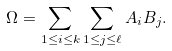Convert formula to latex. <formula><loc_0><loc_0><loc_500><loc_500>\Omega = \sum _ { 1 \leq i \leq k } \sum _ { 1 \leq j \leq \ell } A _ { i } B _ { j } .</formula> 